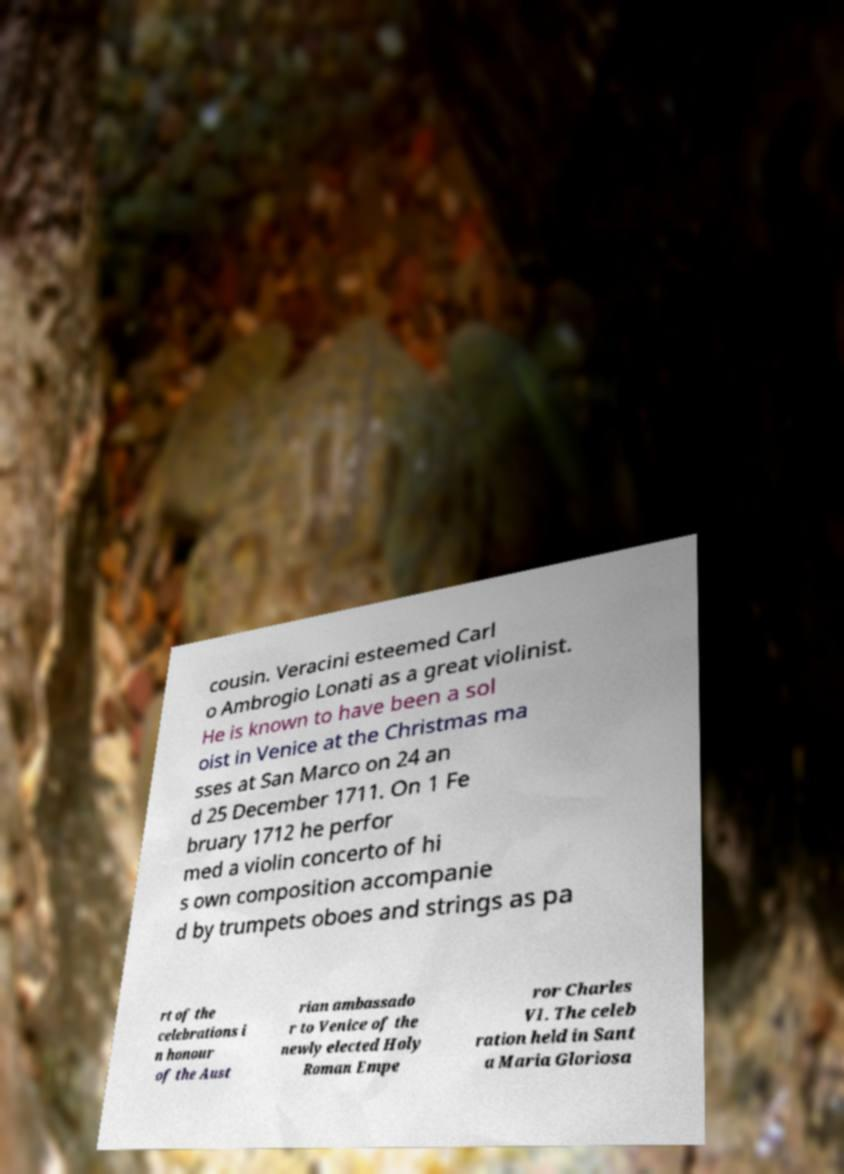There's text embedded in this image that I need extracted. Can you transcribe it verbatim? cousin. Veracini esteemed Carl o Ambrogio Lonati as a great violinist. He is known to have been a sol oist in Venice at the Christmas ma sses at San Marco on 24 an d 25 December 1711. On 1 Fe bruary 1712 he perfor med a violin concerto of hi s own composition accompanie d by trumpets oboes and strings as pa rt of the celebrations i n honour of the Aust rian ambassado r to Venice of the newly elected Holy Roman Empe ror Charles VI. The celeb ration held in Sant a Maria Gloriosa 